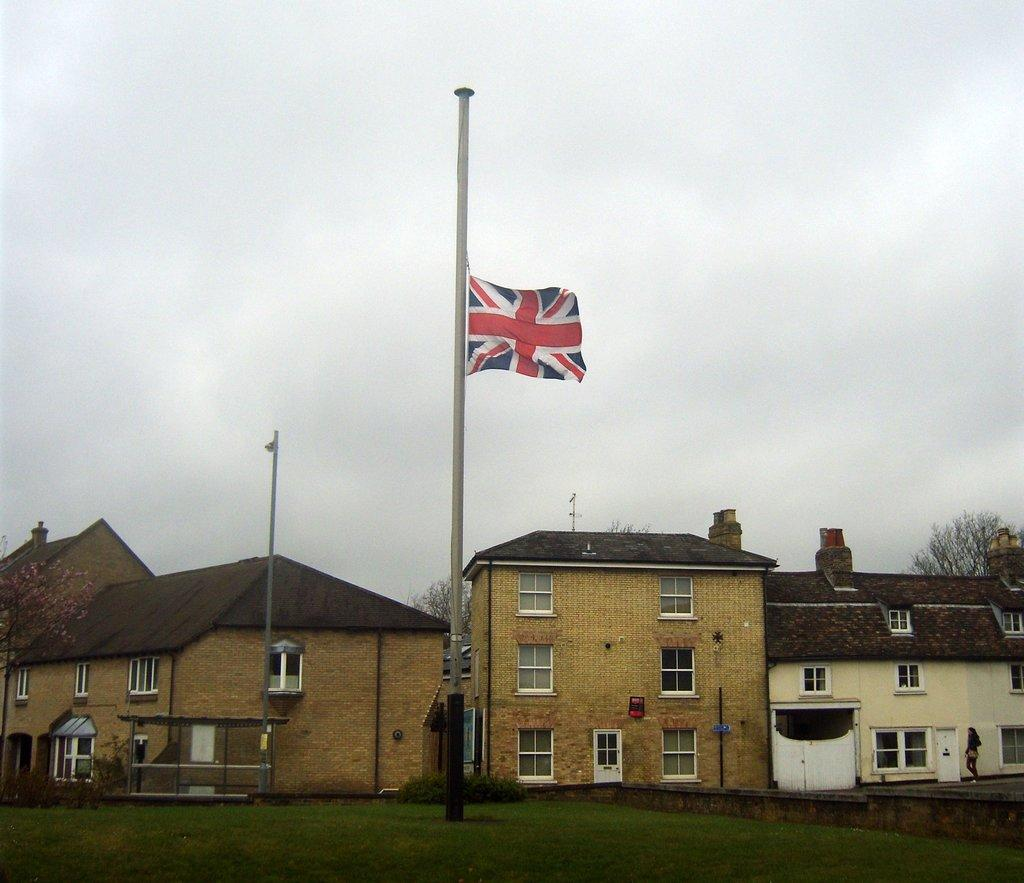What is the main object in the center of the image? There is a flag on a pole in the center of the image. Can you describe the background of the image? There is a woman standing in the background, along with buildings with windows and a tree. The sky is also visible in the background. What type of quilt is being used to cover the flag in the image? There is no quilt present in the image, and the flag is not covered. 